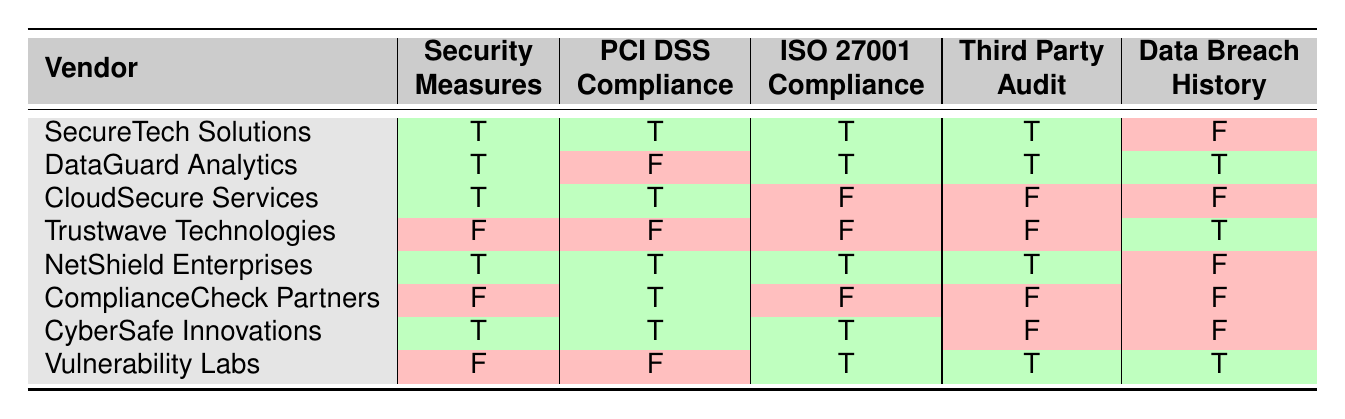What is the PCI DSS compliance status of SecureTech Solutions? The table indicates that SecureTech Solutions has a PCI DSS compliance status marked as true (T).
Answer: true How many vendors have completed a third-party audit? By reviewing the table, we can count the vendors with the third-party audit status marked as true (T). The vendors are SecureTech Solutions, DataGuard Analytics, NetShield Enterprises, and CyberSafe Innovations, totaling four vendors.
Answer: 4 Which vendor has a data breach history marked as true (T) and has implemented security measures? Looking at the table, DataGuard Analytics is the only vendor that has a data breach history marked as true (T) while also having security measures implemented marked as true (T).
Answer: DataGuard Analytics What is the average compliance status (true or false) for ISO 27001 among the listed vendors? There are eight vendors in total. The ISO 27001 compliance is true (T) for SecureTech Solutions, DataGuard Analytics, Vulnerability Labs, CyberSafe Innovations, and false (F) for CloudSecure Services, Trustwave Technologies, and ComplianceCheck Partners, totaling five true and three false. When calculating the average, it is five true out of eight vendors. Therefore, the average status leans towards true.
Answer: true Is there any vendor that has not implemented security measures but has PCI DSS compliance? The table shows ComplianceCheck Partners as the only vendor that has not implemented security measures but has PCI DSS compliance marked as true (T).
Answer: yes How many vendors have both PCI DSS and ISO 27001 compliance status marked as true? The vendors with both PCI DSS and ISO 27001 compliance marked as true (T) based on the table are SecureTech Solutions, NetShield Enterprises, and CyberSafe Innovations, totaling three vendors.
Answer: 3 Which vendor with a data breach history has implemented security measures? The table reveals that DataGuard Analytics is the vendor with a data breach history marked as true (T) and has security measures implemented marked as true (T).
Answer: DataGuard Analytics Which vendor has the best security profile as evidenced by all positive statuses (true) in the table? Examining the table, SecureTech Solutions and NetShield Enterprises both hold a completely positive status (true for all criteria), making them the vendors with the best security profile.
Answer: SecureTech Solutions and NetShield Enterprises What percentage of vendors have undergone a third-party audit? Out of eight vendors, four have undergone a third-party audit (marked as true). To find the percentage, we use the formula (4/8) * 100 = 50%.
Answer: 50% 